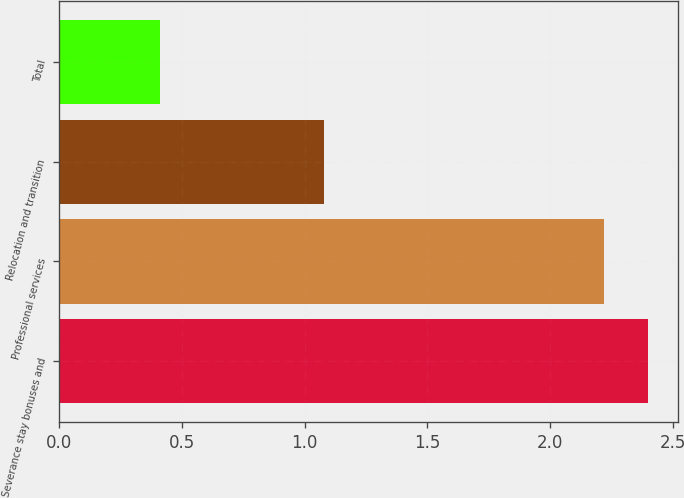<chart> <loc_0><loc_0><loc_500><loc_500><bar_chart><fcel>Severance stay bonuses and<fcel>Professional services<fcel>Relocation and transition<fcel>Total<nl><fcel>2.4<fcel>2.22<fcel>1.08<fcel>0.41<nl></chart> 